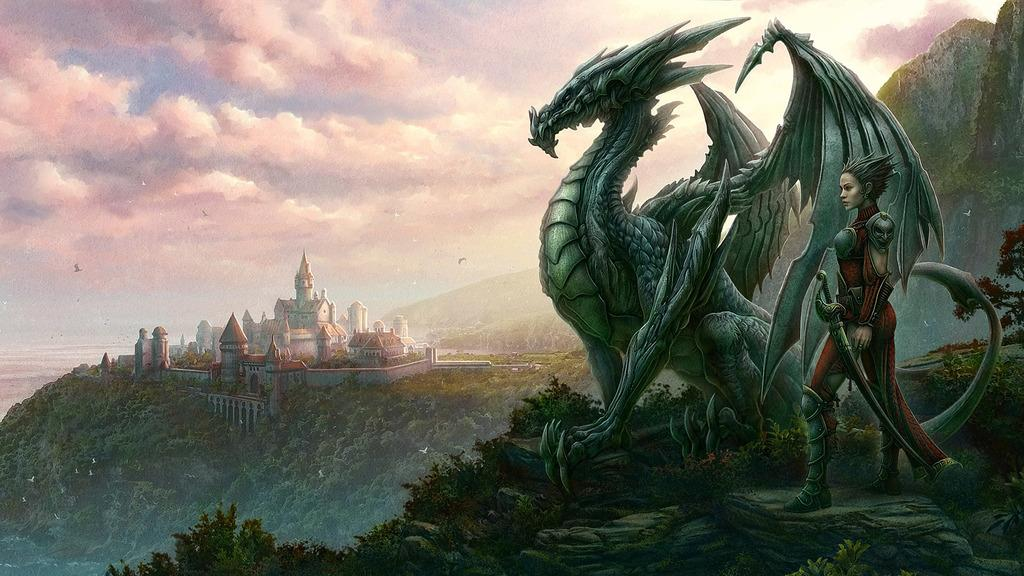Where is the woman located in the image? The woman is on the right side of the image. What is the woman holding in the image? The woman is holding a sword. What is the main subject in the middle of the image? There is a dragon in the middle of the image. What type of structures can be seen on the left side of the image? There are buildings on the left side of the image. What type of vegetation is present on the left side of the image? There are trees and plants on the left side of the image. What type of natural feature is visible on the left side of the image? There are hills on the left side of the image. What type of animals can be seen in the image? There are birds visible in the image. What is visible in the sky in the image? The sky is visible in the image, and there are clouds in the sky. How many circles can be seen in the image? There are no circles present in the image. What color are the woman's eyes in the image? The woman's eyes are not visible in the image, so we cannot determine their color. 